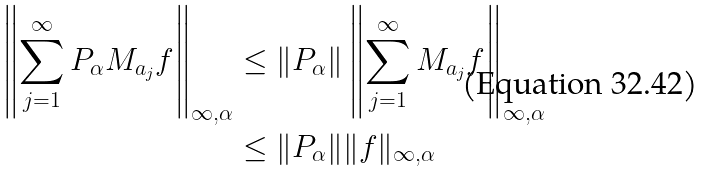Convert formula to latex. <formula><loc_0><loc_0><loc_500><loc_500>\left \| \sum _ { j = 1 } ^ { \infty } P _ { \alpha } M _ { a _ { j } } f \right \| _ { \infty , \alpha } & \leq \| P _ { \alpha } \| \left \| \sum _ { j = 1 } ^ { \infty } M _ { a _ { j } } f \right \| _ { \infty , \alpha } \\ & \leq \| P _ { \alpha } \| \| f \| _ { \infty , \alpha }</formula> 